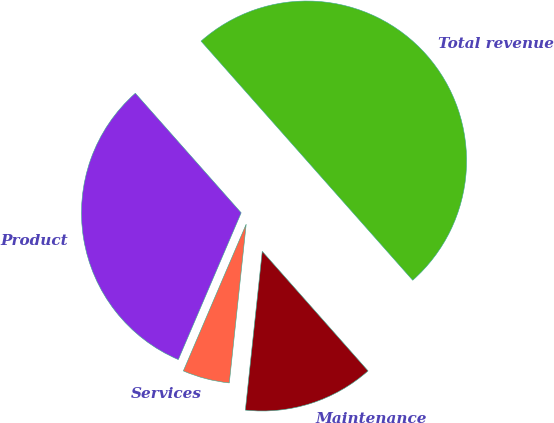<chart> <loc_0><loc_0><loc_500><loc_500><pie_chart><fcel>Product<fcel>Services<fcel>Maintenance<fcel>Total revenue<nl><fcel>32.03%<fcel>4.75%<fcel>13.22%<fcel>50.0%<nl></chart> 